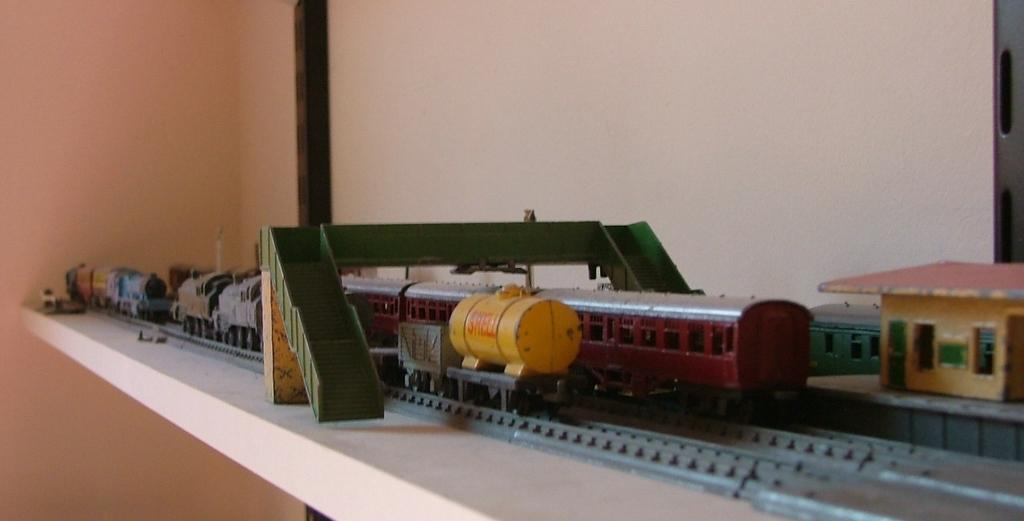What can be seen in the image that is used for storage or display? There is a shelf in the image that is used for storage or display. What is on the shelf in the image? The shelf contains a model of train tracks, which includes trains. Are there any structures in the model? Yes, there is a bridge in the model. What type of shoes can be seen on the bridge in the image? There are no shoes present in the image, and the bridge is part of a model train set, not a real bridge. 